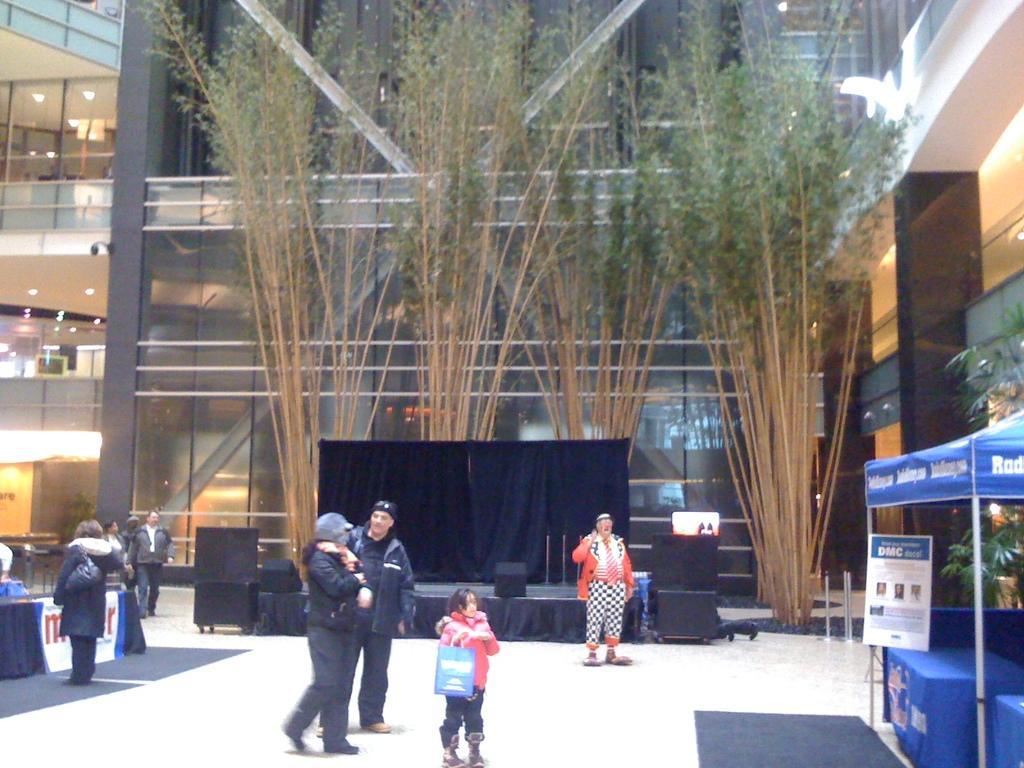Please provide a concise description of this image. In the center of the image we can see the stage, curtains, speakers, board and some people are standing and wearing coats and a girl is holding a bag. In the background of the image we can see the trees, buildings, pillars, railing, lights, roof. On the right side of the image we can see a tent, board, tables. On the tables we can see the clothes. On the left side of the image we can see a table, board and some people are standing. At the bottom of the image we can see the mats, floor and barricades. 